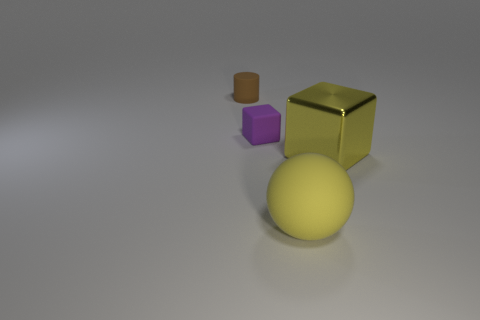Are there any other things that have the same material as the yellow block?
Make the answer very short. No. There is a object that is both to the right of the purple cube and behind the large rubber sphere; what is its material?
Your answer should be compact. Metal. Does the rubber thing in front of the tiny cube have the same color as the big cube?
Keep it short and to the point. Yes. There is a large metallic cube; does it have the same color as the thing that is in front of the yellow cube?
Ensure brevity in your answer.  Yes. Are there any tiny purple rubber blocks behind the purple rubber cube?
Provide a short and direct response. No. Does the big yellow cube have the same material as the purple thing?
Offer a terse response. No. There is a yellow block that is the same size as the yellow ball; what is its material?
Offer a terse response. Metal. How many objects are small objects that are in front of the brown matte cylinder or tiny rubber blocks?
Give a very brief answer. 1. Are there an equal number of small brown objects that are behind the small brown cylinder and large green rubber balls?
Your answer should be compact. Yes. Do the big rubber sphere and the shiny thing have the same color?
Your response must be concise. Yes. 